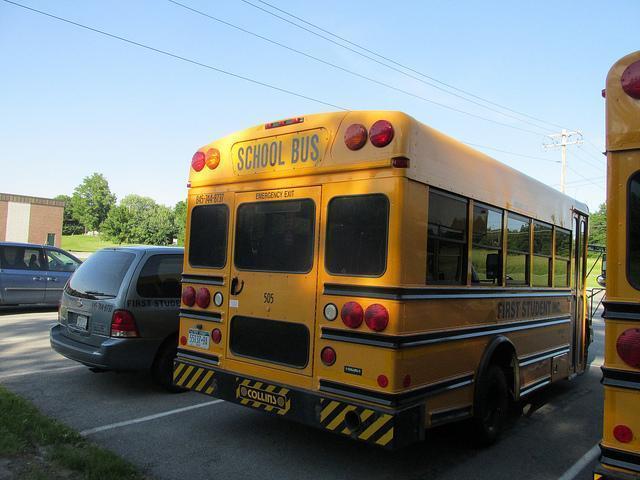How many buses are there?
Give a very brief answer. 2. How many cars are there?
Give a very brief answer. 2. How many cats are shown?
Give a very brief answer. 0. 